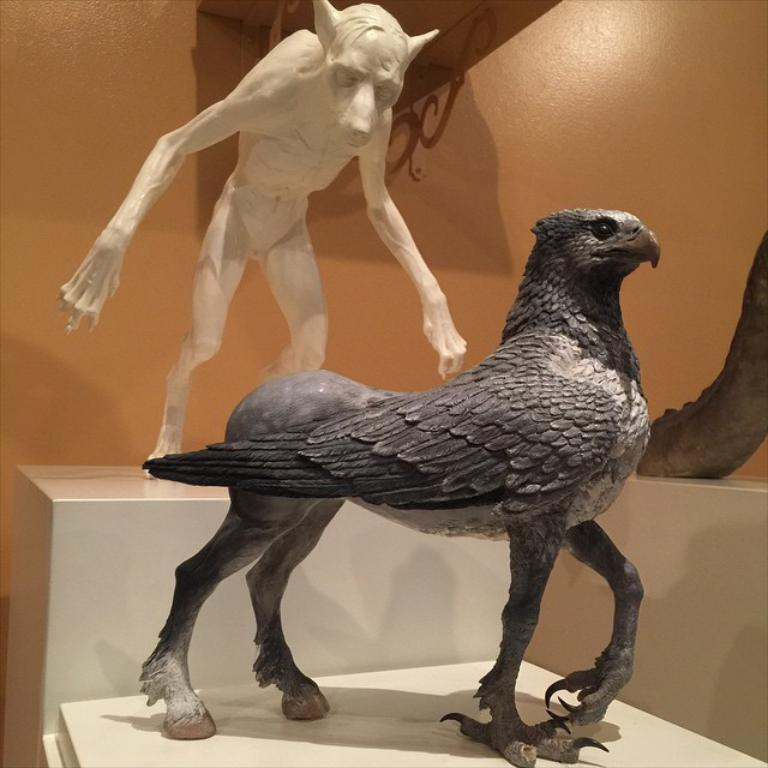What can be seen in the image that represents human figures or forms? There are statues in the image that represent human figures or forms. What are the statues placed on or attached to? The statues are on an object. What type of background can be seen in the image? There is a wall in the image. What type of trousers are the statues wearing in the image? The statues in the image are not wearing trousers, as they are statues and do not have clothing. 